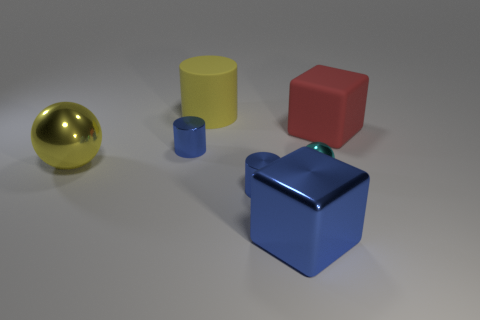There is a cube that is behind the large yellow shiny thing in front of the red object; how big is it?
Your answer should be very brief. Large. Are there an equal number of big matte cubes that are in front of the cyan ball and large metallic objects in front of the big red rubber thing?
Provide a succinct answer. No. There is a large thing that is both in front of the yellow cylinder and left of the blue block; what is it made of?
Your response must be concise. Metal. Do the cyan metallic ball and the cube on the right side of the blue metallic block have the same size?
Offer a terse response. No. What number of other objects are the same color as the tiny ball?
Your answer should be compact. 0. Are there more tiny cyan shiny things that are left of the yellow cylinder than yellow spheres?
Offer a terse response. No. There is a tiny metal sphere that is in front of the tiny metallic thing that is left of the tiny shiny cylinder that is in front of the big metal ball; what color is it?
Your answer should be very brief. Cyan. Does the big sphere have the same material as the small cyan thing?
Your answer should be very brief. Yes. Is there a cyan ball that has the same size as the blue metal cube?
Keep it short and to the point. No. What is the material of the ball that is the same size as the yellow cylinder?
Ensure brevity in your answer.  Metal. 